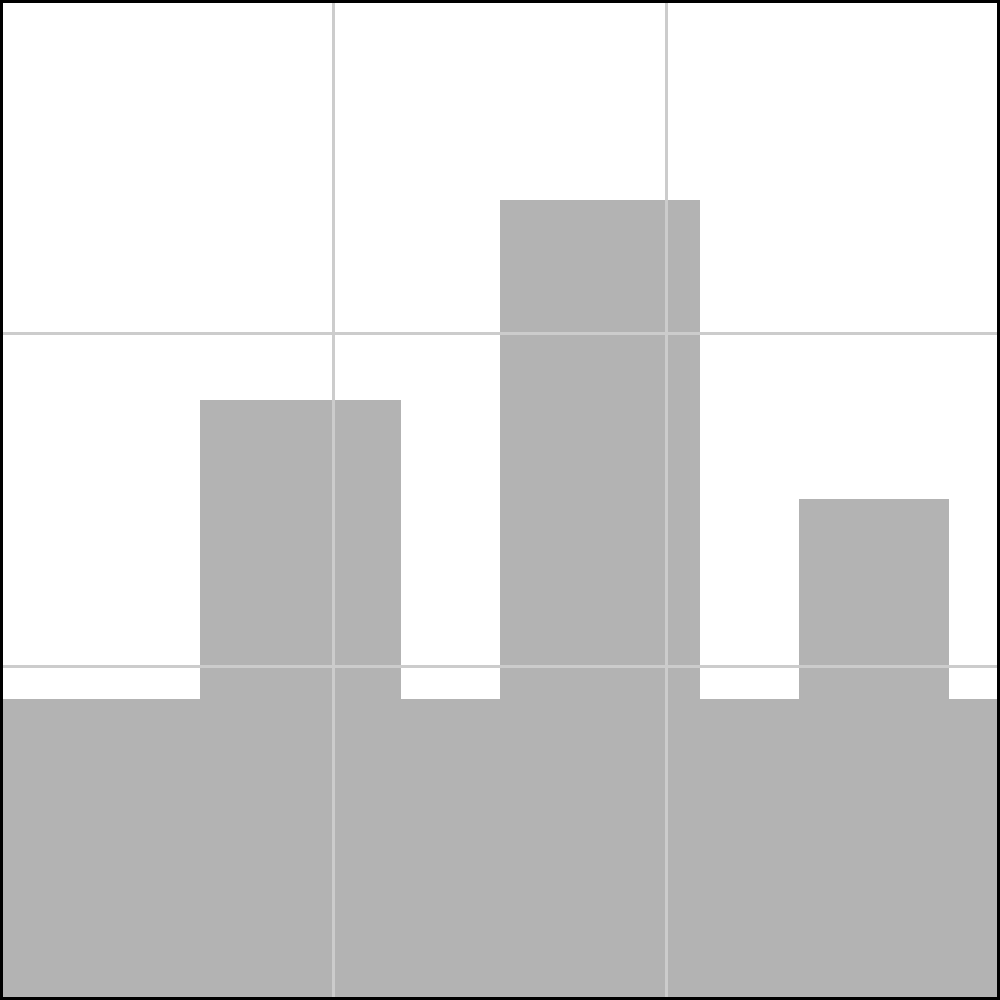In the cityscape composition shown, which key element of the scene is most effectively placed according to the rule of thirds, and how does this placement contribute to the overall balance of the image? To analyze this cityscape composition using the rule of thirds:

1. Identify the rule of thirds grid: The image is divided into a 3x3 grid, creating four intersection points.

2. Locate key elements: 
   - Tallest building: Centered between the left vertical line and the center of the image
   - Cluster of buildings: Spans from the left third to just past the right third
   - Skyline: Roughly aligns with the bottom horizontal third line

3. Evaluate placement:
   - The tallest building is close to, but not directly on, the left vertical third line
   - The cluster of buildings is spread across the frame, utilizing the rule of thirds horizontally
   - The skyline closely aligns with the bottom horizontal third line

4. Assess effectiveness:
   - While the tallest building and building cluster contribute to the composition, their placement is not precisely on the third lines or intersection points
   - The skyline, however, is effectively placed along the bottom horizontal third line

5. Consider balance:
   - The skyline's alignment with the bottom third creates a strong horizontal element
   - This placement balances the vertical elements of the buildings
   - It also creates a pleasing proportion of sky to cityscape (roughly 2:1)

6. Conclude:
   The skyline is the key element most effectively placed according to the rule of thirds. Its alignment with the bottom horizontal third line creates a balanced composition by establishing a clear foreground (buildings) and background (sky) relationship, while also providing a strong horizontal counterpoint to the vertical building elements.
Answer: The skyline, aligned with the bottom horizontal third, effectively balances the composition. 